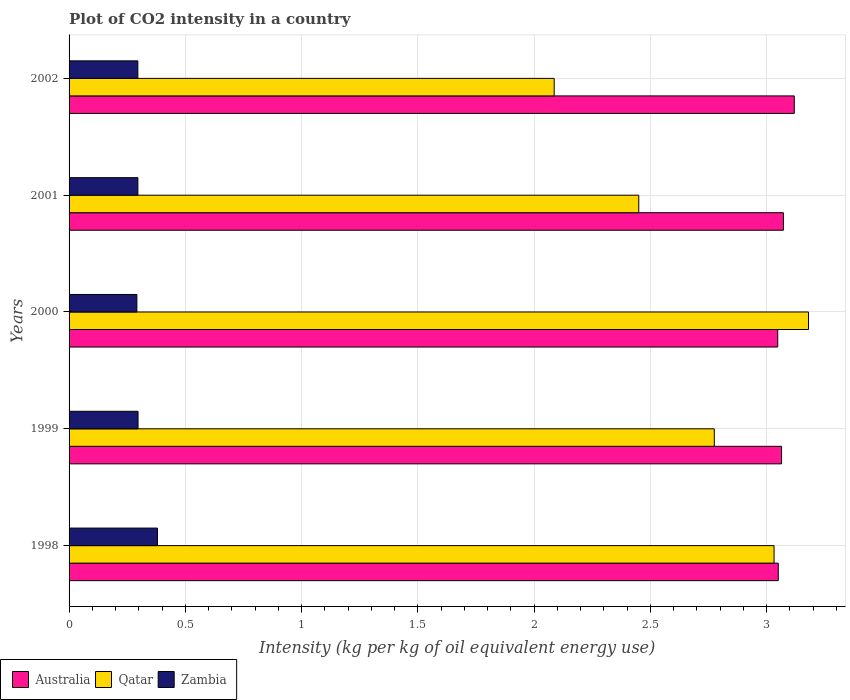Are the number of bars on each tick of the Y-axis equal?
Your response must be concise. Yes. How many bars are there on the 4th tick from the top?
Give a very brief answer. 3. In how many cases, is the number of bars for a given year not equal to the number of legend labels?
Your response must be concise. 0. What is the CO2 intensity in in Qatar in 2002?
Offer a terse response. 2.09. Across all years, what is the maximum CO2 intensity in in Australia?
Offer a very short reply. 3.12. Across all years, what is the minimum CO2 intensity in in Australia?
Keep it short and to the point. 3.05. In which year was the CO2 intensity in in Qatar maximum?
Make the answer very short. 2000. In which year was the CO2 intensity in in Australia minimum?
Provide a succinct answer. 2000. What is the total CO2 intensity in in Qatar in the graph?
Give a very brief answer. 13.52. What is the difference between the CO2 intensity in in Australia in 2000 and that in 2002?
Your response must be concise. -0.07. What is the difference between the CO2 intensity in in Australia in 2001 and the CO2 intensity in in Qatar in 2002?
Keep it short and to the point. 0.99. What is the average CO2 intensity in in Australia per year?
Offer a very short reply. 3.07. In the year 1998, what is the difference between the CO2 intensity in in Qatar and CO2 intensity in in Australia?
Provide a short and direct response. -0.02. In how many years, is the CO2 intensity in in Australia greater than 2.6 kg?
Ensure brevity in your answer.  5. What is the ratio of the CO2 intensity in in Qatar in 2000 to that in 2002?
Your answer should be very brief. 1.52. Is the CO2 intensity in in Qatar in 1999 less than that in 2001?
Offer a terse response. No. Is the difference between the CO2 intensity in in Qatar in 1998 and 2001 greater than the difference between the CO2 intensity in in Australia in 1998 and 2001?
Provide a succinct answer. Yes. What is the difference between the highest and the second highest CO2 intensity in in Australia?
Ensure brevity in your answer.  0.05. What is the difference between the highest and the lowest CO2 intensity in in Zambia?
Give a very brief answer. 0.09. In how many years, is the CO2 intensity in in Qatar greater than the average CO2 intensity in in Qatar taken over all years?
Keep it short and to the point. 3. What does the 2nd bar from the bottom in 1999 represents?
Provide a short and direct response. Qatar. Is it the case that in every year, the sum of the CO2 intensity in in Zambia and CO2 intensity in in Australia is greater than the CO2 intensity in in Qatar?
Provide a short and direct response. Yes. What is the difference between two consecutive major ticks on the X-axis?
Ensure brevity in your answer.  0.5. Are the values on the major ticks of X-axis written in scientific E-notation?
Make the answer very short. No. Does the graph contain any zero values?
Ensure brevity in your answer.  No. Does the graph contain grids?
Your answer should be compact. Yes. How are the legend labels stacked?
Offer a terse response. Horizontal. What is the title of the graph?
Your response must be concise. Plot of CO2 intensity in a country. Does "Turks and Caicos Islands" appear as one of the legend labels in the graph?
Your response must be concise. No. What is the label or title of the X-axis?
Make the answer very short. Intensity (kg per kg of oil equivalent energy use). What is the Intensity (kg per kg of oil equivalent energy use) in Australia in 1998?
Ensure brevity in your answer.  3.05. What is the Intensity (kg per kg of oil equivalent energy use) of Qatar in 1998?
Make the answer very short. 3.03. What is the Intensity (kg per kg of oil equivalent energy use) in Zambia in 1998?
Offer a terse response. 0.38. What is the Intensity (kg per kg of oil equivalent energy use) in Australia in 1999?
Ensure brevity in your answer.  3.06. What is the Intensity (kg per kg of oil equivalent energy use) of Qatar in 1999?
Provide a short and direct response. 2.78. What is the Intensity (kg per kg of oil equivalent energy use) of Zambia in 1999?
Make the answer very short. 0.3. What is the Intensity (kg per kg of oil equivalent energy use) in Australia in 2000?
Keep it short and to the point. 3.05. What is the Intensity (kg per kg of oil equivalent energy use) in Qatar in 2000?
Offer a terse response. 3.18. What is the Intensity (kg per kg of oil equivalent energy use) in Zambia in 2000?
Provide a short and direct response. 0.29. What is the Intensity (kg per kg of oil equivalent energy use) in Australia in 2001?
Your answer should be very brief. 3.07. What is the Intensity (kg per kg of oil equivalent energy use) in Qatar in 2001?
Your answer should be compact. 2.45. What is the Intensity (kg per kg of oil equivalent energy use) of Zambia in 2001?
Ensure brevity in your answer.  0.3. What is the Intensity (kg per kg of oil equivalent energy use) of Australia in 2002?
Offer a very short reply. 3.12. What is the Intensity (kg per kg of oil equivalent energy use) in Qatar in 2002?
Your answer should be compact. 2.09. What is the Intensity (kg per kg of oil equivalent energy use) of Zambia in 2002?
Offer a terse response. 0.3. Across all years, what is the maximum Intensity (kg per kg of oil equivalent energy use) in Australia?
Give a very brief answer. 3.12. Across all years, what is the maximum Intensity (kg per kg of oil equivalent energy use) of Qatar?
Your response must be concise. 3.18. Across all years, what is the maximum Intensity (kg per kg of oil equivalent energy use) of Zambia?
Your answer should be very brief. 0.38. Across all years, what is the minimum Intensity (kg per kg of oil equivalent energy use) of Australia?
Offer a very short reply. 3.05. Across all years, what is the minimum Intensity (kg per kg of oil equivalent energy use) in Qatar?
Give a very brief answer. 2.09. Across all years, what is the minimum Intensity (kg per kg of oil equivalent energy use) in Zambia?
Provide a succinct answer. 0.29. What is the total Intensity (kg per kg of oil equivalent energy use) in Australia in the graph?
Your answer should be very brief. 15.35. What is the total Intensity (kg per kg of oil equivalent energy use) of Qatar in the graph?
Give a very brief answer. 13.52. What is the total Intensity (kg per kg of oil equivalent energy use) in Zambia in the graph?
Your response must be concise. 1.56. What is the difference between the Intensity (kg per kg of oil equivalent energy use) of Australia in 1998 and that in 1999?
Give a very brief answer. -0.01. What is the difference between the Intensity (kg per kg of oil equivalent energy use) of Qatar in 1998 and that in 1999?
Ensure brevity in your answer.  0.26. What is the difference between the Intensity (kg per kg of oil equivalent energy use) of Zambia in 1998 and that in 1999?
Give a very brief answer. 0.08. What is the difference between the Intensity (kg per kg of oil equivalent energy use) in Australia in 1998 and that in 2000?
Your answer should be very brief. 0. What is the difference between the Intensity (kg per kg of oil equivalent energy use) in Qatar in 1998 and that in 2000?
Provide a short and direct response. -0.15. What is the difference between the Intensity (kg per kg of oil equivalent energy use) of Zambia in 1998 and that in 2000?
Make the answer very short. 0.09. What is the difference between the Intensity (kg per kg of oil equivalent energy use) in Australia in 1998 and that in 2001?
Offer a very short reply. -0.02. What is the difference between the Intensity (kg per kg of oil equivalent energy use) in Qatar in 1998 and that in 2001?
Make the answer very short. 0.58. What is the difference between the Intensity (kg per kg of oil equivalent energy use) of Zambia in 1998 and that in 2001?
Your response must be concise. 0.08. What is the difference between the Intensity (kg per kg of oil equivalent energy use) of Australia in 1998 and that in 2002?
Ensure brevity in your answer.  -0.07. What is the difference between the Intensity (kg per kg of oil equivalent energy use) of Qatar in 1998 and that in 2002?
Ensure brevity in your answer.  0.95. What is the difference between the Intensity (kg per kg of oil equivalent energy use) of Zambia in 1998 and that in 2002?
Your answer should be compact. 0.08. What is the difference between the Intensity (kg per kg of oil equivalent energy use) of Australia in 1999 and that in 2000?
Make the answer very short. 0.02. What is the difference between the Intensity (kg per kg of oil equivalent energy use) of Qatar in 1999 and that in 2000?
Give a very brief answer. -0.41. What is the difference between the Intensity (kg per kg of oil equivalent energy use) in Zambia in 1999 and that in 2000?
Provide a short and direct response. 0. What is the difference between the Intensity (kg per kg of oil equivalent energy use) in Australia in 1999 and that in 2001?
Your answer should be compact. -0.01. What is the difference between the Intensity (kg per kg of oil equivalent energy use) in Qatar in 1999 and that in 2001?
Provide a succinct answer. 0.32. What is the difference between the Intensity (kg per kg of oil equivalent energy use) in Zambia in 1999 and that in 2001?
Provide a succinct answer. 0. What is the difference between the Intensity (kg per kg of oil equivalent energy use) in Australia in 1999 and that in 2002?
Your answer should be very brief. -0.05. What is the difference between the Intensity (kg per kg of oil equivalent energy use) of Qatar in 1999 and that in 2002?
Offer a terse response. 0.69. What is the difference between the Intensity (kg per kg of oil equivalent energy use) of Zambia in 1999 and that in 2002?
Make the answer very short. 0. What is the difference between the Intensity (kg per kg of oil equivalent energy use) in Australia in 2000 and that in 2001?
Your answer should be very brief. -0.02. What is the difference between the Intensity (kg per kg of oil equivalent energy use) of Qatar in 2000 and that in 2001?
Provide a succinct answer. 0.73. What is the difference between the Intensity (kg per kg of oil equivalent energy use) of Zambia in 2000 and that in 2001?
Your answer should be very brief. -0. What is the difference between the Intensity (kg per kg of oil equivalent energy use) in Australia in 2000 and that in 2002?
Your answer should be very brief. -0.07. What is the difference between the Intensity (kg per kg of oil equivalent energy use) of Qatar in 2000 and that in 2002?
Your answer should be very brief. 1.09. What is the difference between the Intensity (kg per kg of oil equivalent energy use) in Zambia in 2000 and that in 2002?
Your answer should be very brief. -0. What is the difference between the Intensity (kg per kg of oil equivalent energy use) of Australia in 2001 and that in 2002?
Make the answer very short. -0.05. What is the difference between the Intensity (kg per kg of oil equivalent energy use) in Qatar in 2001 and that in 2002?
Provide a succinct answer. 0.36. What is the difference between the Intensity (kg per kg of oil equivalent energy use) of Australia in 1998 and the Intensity (kg per kg of oil equivalent energy use) of Qatar in 1999?
Ensure brevity in your answer.  0.28. What is the difference between the Intensity (kg per kg of oil equivalent energy use) in Australia in 1998 and the Intensity (kg per kg of oil equivalent energy use) in Zambia in 1999?
Your answer should be very brief. 2.75. What is the difference between the Intensity (kg per kg of oil equivalent energy use) in Qatar in 1998 and the Intensity (kg per kg of oil equivalent energy use) in Zambia in 1999?
Provide a succinct answer. 2.74. What is the difference between the Intensity (kg per kg of oil equivalent energy use) in Australia in 1998 and the Intensity (kg per kg of oil equivalent energy use) in Qatar in 2000?
Your answer should be compact. -0.13. What is the difference between the Intensity (kg per kg of oil equivalent energy use) of Australia in 1998 and the Intensity (kg per kg of oil equivalent energy use) of Zambia in 2000?
Ensure brevity in your answer.  2.76. What is the difference between the Intensity (kg per kg of oil equivalent energy use) in Qatar in 1998 and the Intensity (kg per kg of oil equivalent energy use) in Zambia in 2000?
Offer a terse response. 2.74. What is the difference between the Intensity (kg per kg of oil equivalent energy use) in Australia in 1998 and the Intensity (kg per kg of oil equivalent energy use) in Qatar in 2001?
Offer a very short reply. 0.6. What is the difference between the Intensity (kg per kg of oil equivalent energy use) in Australia in 1998 and the Intensity (kg per kg of oil equivalent energy use) in Zambia in 2001?
Your response must be concise. 2.75. What is the difference between the Intensity (kg per kg of oil equivalent energy use) of Qatar in 1998 and the Intensity (kg per kg of oil equivalent energy use) of Zambia in 2001?
Make the answer very short. 2.74. What is the difference between the Intensity (kg per kg of oil equivalent energy use) of Australia in 1998 and the Intensity (kg per kg of oil equivalent energy use) of Qatar in 2002?
Keep it short and to the point. 0.96. What is the difference between the Intensity (kg per kg of oil equivalent energy use) of Australia in 1998 and the Intensity (kg per kg of oil equivalent energy use) of Zambia in 2002?
Give a very brief answer. 2.75. What is the difference between the Intensity (kg per kg of oil equivalent energy use) in Qatar in 1998 and the Intensity (kg per kg of oil equivalent energy use) in Zambia in 2002?
Your response must be concise. 2.74. What is the difference between the Intensity (kg per kg of oil equivalent energy use) of Australia in 1999 and the Intensity (kg per kg of oil equivalent energy use) of Qatar in 2000?
Give a very brief answer. -0.12. What is the difference between the Intensity (kg per kg of oil equivalent energy use) of Australia in 1999 and the Intensity (kg per kg of oil equivalent energy use) of Zambia in 2000?
Your answer should be compact. 2.77. What is the difference between the Intensity (kg per kg of oil equivalent energy use) of Qatar in 1999 and the Intensity (kg per kg of oil equivalent energy use) of Zambia in 2000?
Your answer should be very brief. 2.48. What is the difference between the Intensity (kg per kg of oil equivalent energy use) of Australia in 1999 and the Intensity (kg per kg of oil equivalent energy use) of Qatar in 2001?
Offer a terse response. 0.61. What is the difference between the Intensity (kg per kg of oil equivalent energy use) of Australia in 1999 and the Intensity (kg per kg of oil equivalent energy use) of Zambia in 2001?
Offer a very short reply. 2.77. What is the difference between the Intensity (kg per kg of oil equivalent energy use) of Qatar in 1999 and the Intensity (kg per kg of oil equivalent energy use) of Zambia in 2001?
Offer a terse response. 2.48. What is the difference between the Intensity (kg per kg of oil equivalent energy use) in Australia in 1999 and the Intensity (kg per kg of oil equivalent energy use) in Qatar in 2002?
Your answer should be very brief. 0.98. What is the difference between the Intensity (kg per kg of oil equivalent energy use) of Australia in 1999 and the Intensity (kg per kg of oil equivalent energy use) of Zambia in 2002?
Ensure brevity in your answer.  2.77. What is the difference between the Intensity (kg per kg of oil equivalent energy use) in Qatar in 1999 and the Intensity (kg per kg of oil equivalent energy use) in Zambia in 2002?
Provide a succinct answer. 2.48. What is the difference between the Intensity (kg per kg of oil equivalent energy use) in Australia in 2000 and the Intensity (kg per kg of oil equivalent energy use) in Qatar in 2001?
Make the answer very short. 0.6. What is the difference between the Intensity (kg per kg of oil equivalent energy use) of Australia in 2000 and the Intensity (kg per kg of oil equivalent energy use) of Zambia in 2001?
Provide a short and direct response. 2.75. What is the difference between the Intensity (kg per kg of oil equivalent energy use) of Qatar in 2000 and the Intensity (kg per kg of oil equivalent energy use) of Zambia in 2001?
Your answer should be compact. 2.88. What is the difference between the Intensity (kg per kg of oil equivalent energy use) of Australia in 2000 and the Intensity (kg per kg of oil equivalent energy use) of Qatar in 2002?
Give a very brief answer. 0.96. What is the difference between the Intensity (kg per kg of oil equivalent energy use) of Australia in 2000 and the Intensity (kg per kg of oil equivalent energy use) of Zambia in 2002?
Make the answer very short. 2.75. What is the difference between the Intensity (kg per kg of oil equivalent energy use) in Qatar in 2000 and the Intensity (kg per kg of oil equivalent energy use) in Zambia in 2002?
Offer a terse response. 2.88. What is the difference between the Intensity (kg per kg of oil equivalent energy use) in Australia in 2001 and the Intensity (kg per kg of oil equivalent energy use) in Qatar in 2002?
Give a very brief answer. 0.99. What is the difference between the Intensity (kg per kg of oil equivalent energy use) in Australia in 2001 and the Intensity (kg per kg of oil equivalent energy use) in Zambia in 2002?
Your response must be concise. 2.78. What is the difference between the Intensity (kg per kg of oil equivalent energy use) of Qatar in 2001 and the Intensity (kg per kg of oil equivalent energy use) of Zambia in 2002?
Your answer should be compact. 2.15. What is the average Intensity (kg per kg of oil equivalent energy use) of Australia per year?
Provide a short and direct response. 3.07. What is the average Intensity (kg per kg of oil equivalent energy use) in Qatar per year?
Your response must be concise. 2.7. What is the average Intensity (kg per kg of oil equivalent energy use) in Zambia per year?
Your answer should be very brief. 0.31. In the year 1998, what is the difference between the Intensity (kg per kg of oil equivalent energy use) of Australia and Intensity (kg per kg of oil equivalent energy use) of Qatar?
Ensure brevity in your answer.  0.02. In the year 1998, what is the difference between the Intensity (kg per kg of oil equivalent energy use) in Australia and Intensity (kg per kg of oil equivalent energy use) in Zambia?
Give a very brief answer. 2.67. In the year 1998, what is the difference between the Intensity (kg per kg of oil equivalent energy use) in Qatar and Intensity (kg per kg of oil equivalent energy use) in Zambia?
Offer a very short reply. 2.65. In the year 1999, what is the difference between the Intensity (kg per kg of oil equivalent energy use) of Australia and Intensity (kg per kg of oil equivalent energy use) of Qatar?
Ensure brevity in your answer.  0.29. In the year 1999, what is the difference between the Intensity (kg per kg of oil equivalent energy use) in Australia and Intensity (kg per kg of oil equivalent energy use) in Zambia?
Your answer should be compact. 2.77. In the year 1999, what is the difference between the Intensity (kg per kg of oil equivalent energy use) in Qatar and Intensity (kg per kg of oil equivalent energy use) in Zambia?
Your answer should be compact. 2.48. In the year 2000, what is the difference between the Intensity (kg per kg of oil equivalent energy use) in Australia and Intensity (kg per kg of oil equivalent energy use) in Qatar?
Give a very brief answer. -0.13. In the year 2000, what is the difference between the Intensity (kg per kg of oil equivalent energy use) of Australia and Intensity (kg per kg of oil equivalent energy use) of Zambia?
Provide a succinct answer. 2.76. In the year 2000, what is the difference between the Intensity (kg per kg of oil equivalent energy use) in Qatar and Intensity (kg per kg of oil equivalent energy use) in Zambia?
Ensure brevity in your answer.  2.89. In the year 2001, what is the difference between the Intensity (kg per kg of oil equivalent energy use) in Australia and Intensity (kg per kg of oil equivalent energy use) in Qatar?
Your answer should be compact. 0.62. In the year 2001, what is the difference between the Intensity (kg per kg of oil equivalent energy use) of Australia and Intensity (kg per kg of oil equivalent energy use) of Zambia?
Make the answer very short. 2.78. In the year 2001, what is the difference between the Intensity (kg per kg of oil equivalent energy use) in Qatar and Intensity (kg per kg of oil equivalent energy use) in Zambia?
Ensure brevity in your answer.  2.15. In the year 2002, what is the difference between the Intensity (kg per kg of oil equivalent energy use) in Australia and Intensity (kg per kg of oil equivalent energy use) in Qatar?
Give a very brief answer. 1.03. In the year 2002, what is the difference between the Intensity (kg per kg of oil equivalent energy use) in Australia and Intensity (kg per kg of oil equivalent energy use) in Zambia?
Your answer should be compact. 2.82. In the year 2002, what is the difference between the Intensity (kg per kg of oil equivalent energy use) in Qatar and Intensity (kg per kg of oil equivalent energy use) in Zambia?
Provide a short and direct response. 1.79. What is the ratio of the Intensity (kg per kg of oil equivalent energy use) in Australia in 1998 to that in 1999?
Make the answer very short. 1. What is the ratio of the Intensity (kg per kg of oil equivalent energy use) in Qatar in 1998 to that in 1999?
Provide a succinct answer. 1.09. What is the ratio of the Intensity (kg per kg of oil equivalent energy use) in Zambia in 1998 to that in 1999?
Make the answer very short. 1.28. What is the ratio of the Intensity (kg per kg of oil equivalent energy use) in Qatar in 1998 to that in 2000?
Your response must be concise. 0.95. What is the ratio of the Intensity (kg per kg of oil equivalent energy use) in Zambia in 1998 to that in 2000?
Provide a short and direct response. 1.3. What is the ratio of the Intensity (kg per kg of oil equivalent energy use) of Qatar in 1998 to that in 2001?
Your answer should be compact. 1.24. What is the ratio of the Intensity (kg per kg of oil equivalent energy use) in Zambia in 1998 to that in 2001?
Offer a terse response. 1.28. What is the ratio of the Intensity (kg per kg of oil equivalent energy use) in Australia in 1998 to that in 2002?
Offer a very short reply. 0.98. What is the ratio of the Intensity (kg per kg of oil equivalent energy use) in Qatar in 1998 to that in 2002?
Your answer should be very brief. 1.45. What is the ratio of the Intensity (kg per kg of oil equivalent energy use) in Zambia in 1998 to that in 2002?
Offer a terse response. 1.29. What is the ratio of the Intensity (kg per kg of oil equivalent energy use) in Australia in 1999 to that in 2000?
Your answer should be very brief. 1.01. What is the ratio of the Intensity (kg per kg of oil equivalent energy use) of Qatar in 1999 to that in 2000?
Make the answer very short. 0.87. What is the ratio of the Intensity (kg per kg of oil equivalent energy use) of Zambia in 1999 to that in 2000?
Keep it short and to the point. 1.02. What is the ratio of the Intensity (kg per kg of oil equivalent energy use) of Qatar in 1999 to that in 2001?
Your response must be concise. 1.13. What is the ratio of the Intensity (kg per kg of oil equivalent energy use) in Zambia in 1999 to that in 2001?
Your response must be concise. 1. What is the ratio of the Intensity (kg per kg of oil equivalent energy use) of Australia in 1999 to that in 2002?
Your response must be concise. 0.98. What is the ratio of the Intensity (kg per kg of oil equivalent energy use) in Qatar in 1999 to that in 2002?
Offer a very short reply. 1.33. What is the ratio of the Intensity (kg per kg of oil equivalent energy use) of Zambia in 1999 to that in 2002?
Keep it short and to the point. 1. What is the ratio of the Intensity (kg per kg of oil equivalent energy use) of Qatar in 2000 to that in 2001?
Your answer should be very brief. 1.3. What is the ratio of the Intensity (kg per kg of oil equivalent energy use) in Zambia in 2000 to that in 2001?
Keep it short and to the point. 0.99. What is the ratio of the Intensity (kg per kg of oil equivalent energy use) in Australia in 2000 to that in 2002?
Offer a terse response. 0.98. What is the ratio of the Intensity (kg per kg of oil equivalent energy use) in Qatar in 2000 to that in 2002?
Keep it short and to the point. 1.52. What is the ratio of the Intensity (kg per kg of oil equivalent energy use) in Zambia in 2000 to that in 2002?
Make the answer very short. 0.99. What is the ratio of the Intensity (kg per kg of oil equivalent energy use) in Qatar in 2001 to that in 2002?
Your answer should be compact. 1.17. What is the difference between the highest and the second highest Intensity (kg per kg of oil equivalent energy use) in Australia?
Give a very brief answer. 0.05. What is the difference between the highest and the second highest Intensity (kg per kg of oil equivalent energy use) of Qatar?
Make the answer very short. 0.15. What is the difference between the highest and the second highest Intensity (kg per kg of oil equivalent energy use) of Zambia?
Provide a succinct answer. 0.08. What is the difference between the highest and the lowest Intensity (kg per kg of oil equivalent energy use) in Australia?
Provide a succinct answer. 0.07. What is the difference between the highest and the lowest Intensity (kg per kg of oil equivalent energy use) in Qatar?
Your response must be concise. 1.09. What is the difference between the highest and the lowest Intensity (kg per kg of oil equivalent energy use) of Zambia?
Ensure brevity in your answer.  0.09. 